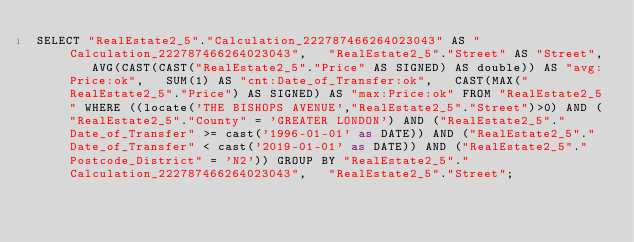Convert code to text. <code><loc_0><loc_0><loc_500><loc_500><_SQL_>SELECT "RealEstate2_5"."Calculation_222787466264023043" AS "Calculation_222787466264023043",   "RealEstate2_5"."Street" AS "Street",   AVG(CAST(CAST("RealEstate2_5"."Price" AS SIGNED) AS double)) AS "avg:Price:ok",   SUM(1) AS "cnt:Date_of_Transfer:ok",   CAST(MAX("RealEstate2_5"."Price") AS SIGNED) AS "max:Price:ok" FROM "RealEstate2_5" WHERE ((locate('THE BISHOPS AVENUE',"RealEstate2_5"."Street")>0) AND ("RealEstate2_5"."County" = 'GREATER LONDON') AND ("RealEstate2_5"."Date_of_Transfer" >= cast('1996-01-01' as DATE)) AND ("RealEstate2_5"."Date_of_Transfer" < cast('2019-01-01' as DATE)) AND ("RealEstate2_5"."Postcode_District" = 'N2')) GROUP BY "RealEstate2_5"."Calculation_222787466264023043",   "RealEstate2_5"."Street";
</code> 